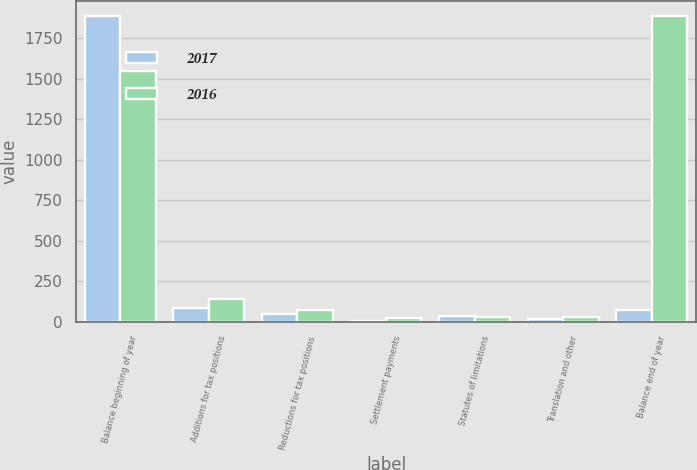Convert chart to OTSL. <chart><loc_0><loc_0><loc_500><loc_500><stacked_bar_chart><ecel><fcel>Balance beginning of year<fcel>Additions for tax positions<fcel>Reductions for tax positions<fcel>Settlement payments<fcel>Statutes of limitations<fcel>Translation and other<fcel>Balance end of year<nl><fcel>2017<fcel>1885<fcel>86<fcel>51<fcel>4<fcel>33<fcel>20<fcel>70<nl><fcel>2016<fcel>1547<fcel>139<fcel>70<fcel>26<fcel>27<fcel>27<fcel>1885<nl></chart> 